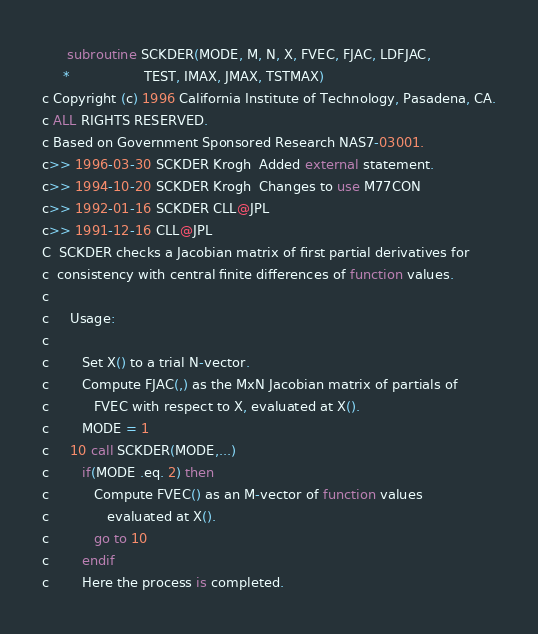Convert code to text. <code><loc_0><loc_0><loc_500><loc_500><_FORTRAN_>      subroutine SCKDER(MODE, M, N, X, FVEC, FJAC, LDFJAC,
     *                  TEST, IMAX, JMAX, TSTMAX)
c Copyright (c) 1996 California Institute of Technology, Pasadena, CA.
c ALL RIGHTS RESERVED.
c Based on Government Sponsored Research NAS7-03001.
c>> 1996-03-30 SCKDER Krogh  Added external statement.
c>> 1994-10-20 SCKDER Krogh  Changes to use M77CON
c>> 1992-01-16 SCKDER CLL@JPL
c>> 1991-12-16 CLL@JPL
C  SCKDER checks a Jacobian matrix of first partial derivatives for
c  consistency with central finite differences of function values.
c
c     Usage:
c
c        Set X() to a trial N-vector.
c        Compute FJAC(,) as the MxN Jacobian matrix of partials of
c           FVEC with respect to X, evaluated at X().
c        MODE = 1
c     10 call SCKDER(MODE,...)
c        if(MODE .eq. 2) then
c           Compute FVEC() as an M-vector of function values
c              evaluated at X().
c           go to 10
c        endif
c        Here the process is completed.</code> 